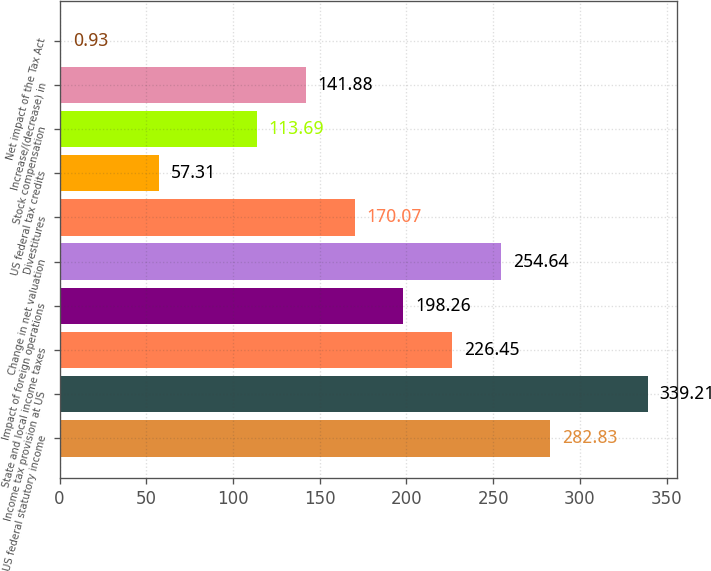Convert chart. <chart><loc_0><loc_0><loc_500><loc_500><bar_chart><fcel>US federal statutory income<fcel>Income tax provision at US<fcel>State and local income taxes<fcel>Impact of foreign operations<fcel>Change in net valuation<fcel>Divestitures<fcel>US federal tax credits<fcel>Stock compensation<fcel>Increase/(decrease) in<fcel>Net impact of the Tax Act<nl><fcel>282.83<fcel>339.21<fcel>226.45<fcel>198.26<fcel>254.64<fcel>170.07<fcel>57.31<fcel>113.69<fcel>141.88<fcel>0.93<nl></chart> 